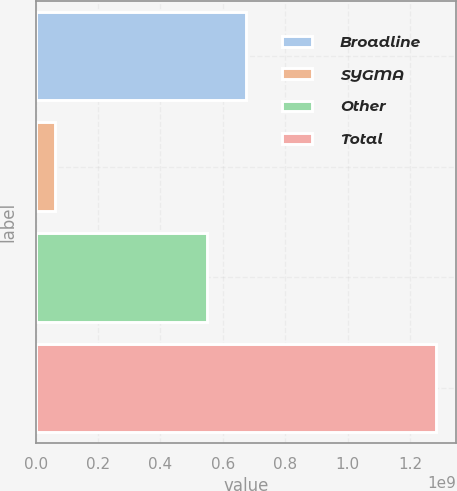<chart> <loc_0><loc_0><loc_500><loc_500><bar_chart><fcel>Broadline<fcel>SYGMA<fcel>Other<fcel>Total<nl><fcel>6.74682e+08<fcel>6.066e+07<fcel>5.49117e+08<fcel>1.28446e+09<nl></chart> 